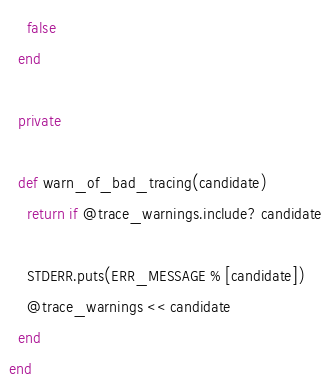<code> <loc_0><loc_0><loc_500><loc_500><_Ruby_>
    false
  end

  private

  def warn_of_bad_tracing(candidate)
    return if @trace_warnings.include? candidate

    STDERR.puts(ERR_MESSAGE % [candidate])
    @trace_warnings << candidate
  end
end
</code> 